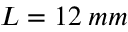Convert formula to latex. <formula><loc_0><loc_0><loc_500><loc_500>L = 1 2 \, m m</formula> 